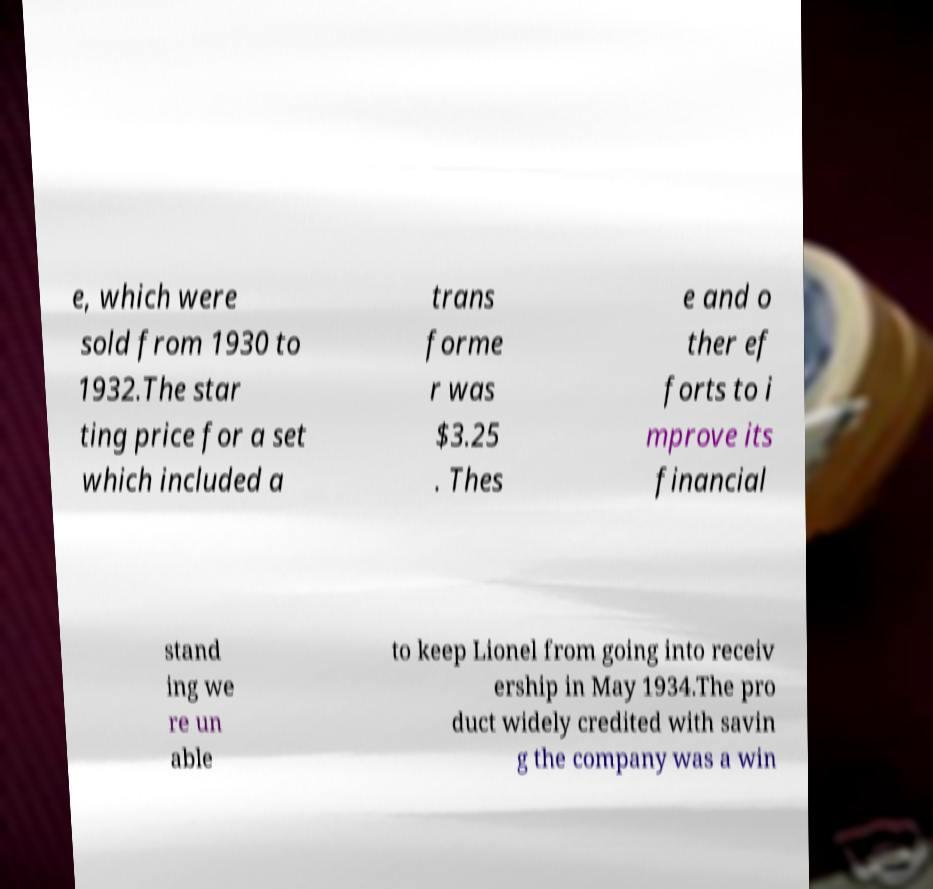I need the written content from this picture converted into text. Can you do that? e, which were sold from 1930 to 1932.The star ting price for a set which included a trans forme r was $3.25 . Thes e and o ther ef forts to i mprove its financial stand ing we re un able to keep Lionel from going into receiv ership in May 1934.The pro duct widely credited with savin g the company was a win 